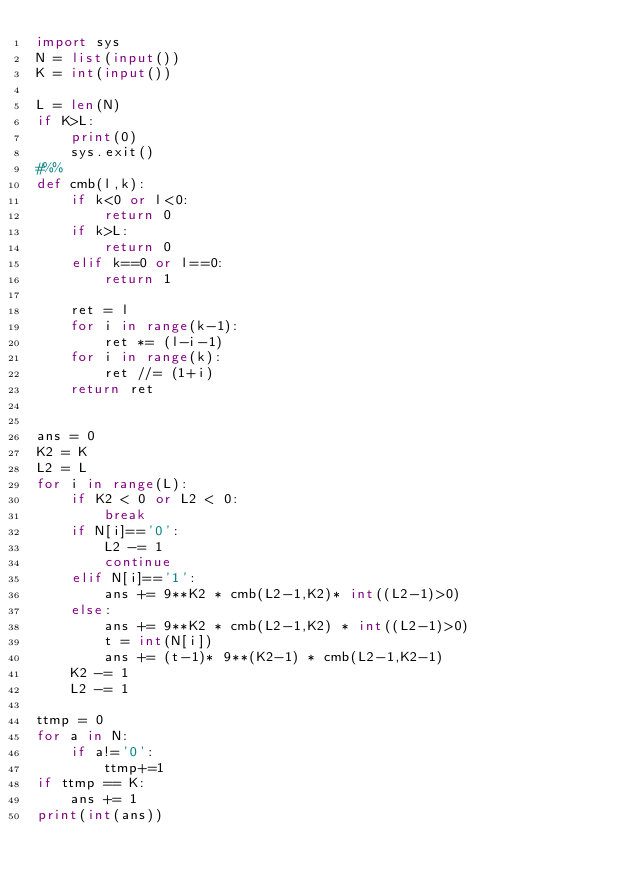<code> <loc_0><loc_0><loc_500><loc_500><_Python_>import sys 
N = list(input())
K = int(input())

L = len(N)
if K>L:
    print(0)
    sys.exit()
#%%
def cmb(l,k):
    if k<0 or l<0:
        return 0
    if k>L:
        return 0
    elif k==0 or l==0:
        return 1
    
    ret = l
    for i in range(k-1):
        ret *= (l-i-1)
    for i in range(k):
        ret //= (1+i)
    return ret


ans = 0
K2 = K
L2 = L
for i in range(L):
    if K2 < 0 or L2 < 0:
        break
    if N[i]=='0':
        L2 -= 1
        continue
    elif N[i]=='1':
        ans += 9**K2 * cmb(L2-1,K2)* int((L2-1)>0)
    else:
        ans += 9**K2 * cmb(L2-1,K2) * int((L2-1)>0)
        t = int(N[i])
        ans += (t-1)* 9**(K2-1) * cmb(L2-1,K2-1)
    K2 -= 1
    L2 -= 1

ttmp = 0
for a in N:
    if a!='0':
        ttmp+=1
if ttmp == K:
    ans += 1
print(int(ans))</code> 